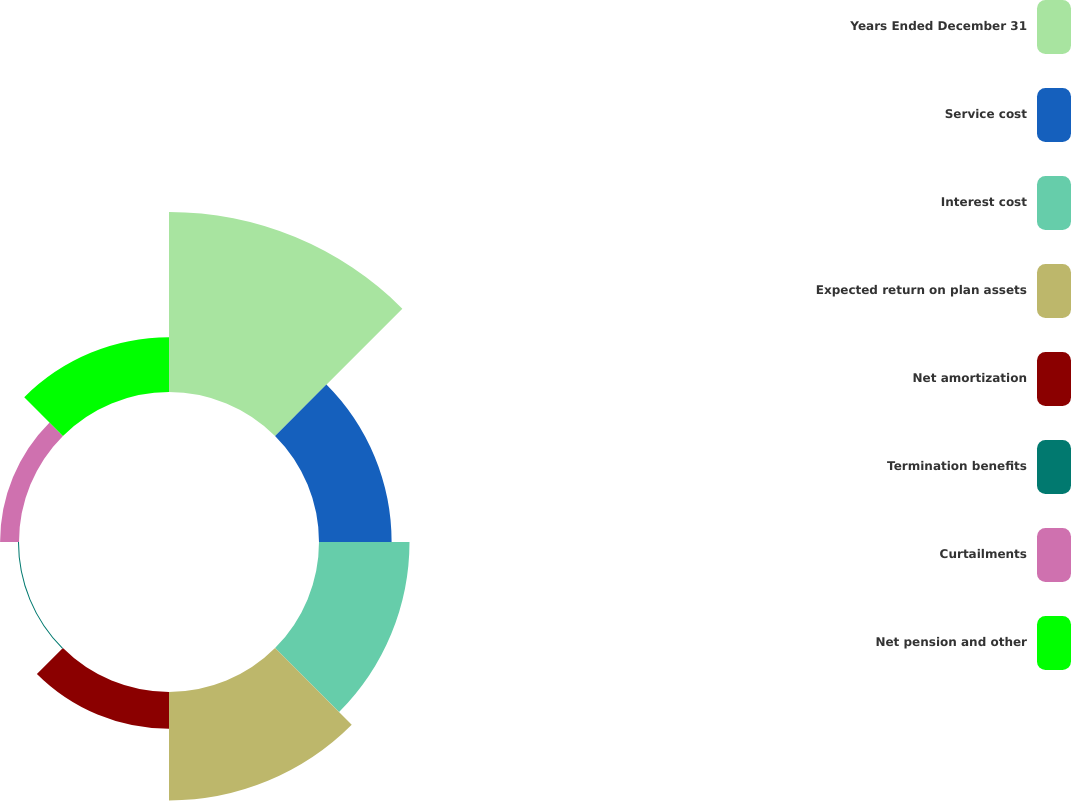<chart> <loc_0><loc_0><loc_500><loc_500><pie_chart><fcel>Years Ended December 31<fcel>Service cost<fcel>Interest cost<fcel>Expected return on plan assets<fcel>Net amortization<fcel>Termination benefits<fcel>Curtailments<fcel>Net pension and other<nl><fcel>31.98%<fcel>12.9%<fcel>16.08%<fcel>19.26%<fcel>6.54%<fcel>0.18%<fcel>3.36%<fcel>9.72%<nl></chart> 